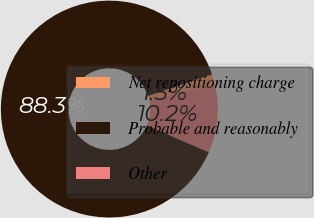<chart> <loc_0><loc_0><loc_500><loc_500><pie_chart><fcel>Net repositioning charge<fcel>Probable and reasonably<fcel>Other<nl><fcel>1.5%<fcel>88.31%<fcel>10.18%<nl></chart> 